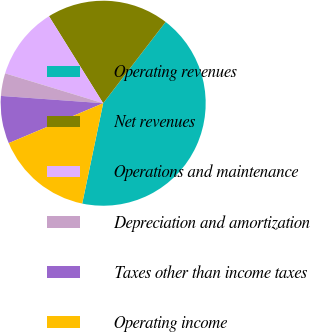Convert chart. <chart><loc_0><loc_0><loc_500><loc_500><pie_chart><fcel>Operating revenues<fcel>Net revenues<fcel>Operations and maintenance<fcel>Depreciation and amortization<fcel>Taxes other than income taxes<fcel>Operating income<nl><fcel>42.86%<fcel>19.29%<fcel>11.43%<fcel>3.57%<fcel>7.5%<fcel>15.36%<nl></chart> 